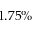<formula> <loc_0><loc_0><loc_500><loc_500>1 . 7 5 \%</formula> 